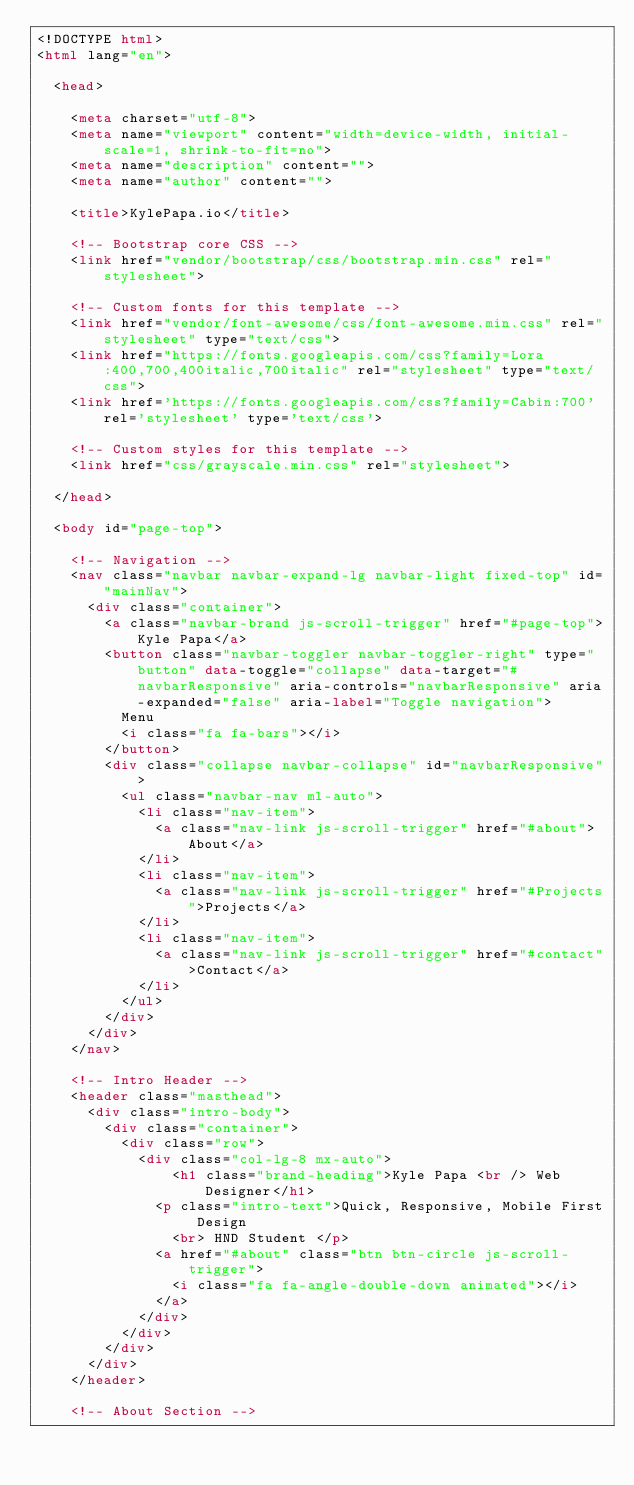<code> <loc_0><loc_0><loc_500><loc_500><_HTML_><!DOCTYPE html>
<html lang="en">

  <head>

    <meta charset="utf-8">
    <meta name="viewport" content="width=device-width, initial-scale=1, shrink-to-fit=no">
    <meta name="description" content="">
    <meta name="author" content="">

    <title>KylePapa.io</title>

    <!-- Bootstrap core CSS -->
    <link href="vendor/bootstrap/css/bootstrap.min.css" rel="stylesheet">

    <!-- Custom fonts for this template -->
    <link href="vendor/font-awesome/css/font-awesome.min.css" rel="stylesheet" type="text/css">
    <link href="https://fonts.googleapis.com/css?family=Lora:400,700,400italic,700italic" rel="stylesheet" type="text/css">
    <link href='https://fonts.googleapis.com/css?family=Cabin:700' rel='stylesheet' type='text/css'>

    <!-- Custom styles for this template -->
    <link href="css/grayscale.min.css" rel="stylesheet">

  </head>

  <body id="page-top">

    <!-- Navigation -->
    <nav class="navbar navbar-expand-lg navbar-light fixed-top" id="mainNav">
      <div class="container">
        <a class="navbar-brand js-scroll-trigger" href="#page-top">Kyle Papa</a>
        <button class="navbar-toggler navbar-toggler-right" type="button" data-toggle="collapse" data-target="#navbarResponsive" aria-controls="navbarResponsive" aria-expanded="false" aria-label="Toggle navigation">
          Menu
          <i class="fa fa-bars"></i>
        </button>
        <div class="collapse navbar-collapse" id="navbarResponsive">
          <ul class="navbar-nav ml-auto">
            <li class="nav-item">
              <a class="nav-link js-scroll-trigger" href="#about">About</a>
            </li>
            <li class="nav-item">
              <a class="nav-link js-scroll-trigger" href="#Projects">Projects</a>
            </li>
            <li class="nav-item">
              <a class="nav-link js-scroll-trigger" href="#contact">Contact</a>
            </li>
          </ul>
        </div>
      </div>
    </nav>

    <!-- Intro Header -->
    <header class="masthead">
      <div class="intro-body">
        <div class="container">
          <div class="row">
            <div class="col-lg-8 mx-auto">
                <h1 class="brand-heading">Kyle Papa <br /> Web Designer</h1>
              <p class="intro-text">Quick, Responsive, Mobile First Design
                <br> HND Student </p>
              <a href="#about" class="btn btn-circle js-scroll-trigger">
                <i class="fa fa-angle-double-down animated"></i>
              </a>
            </div>
          </div>
        </div>
      </div>
    </header>

    <!-- About Section --></code> 